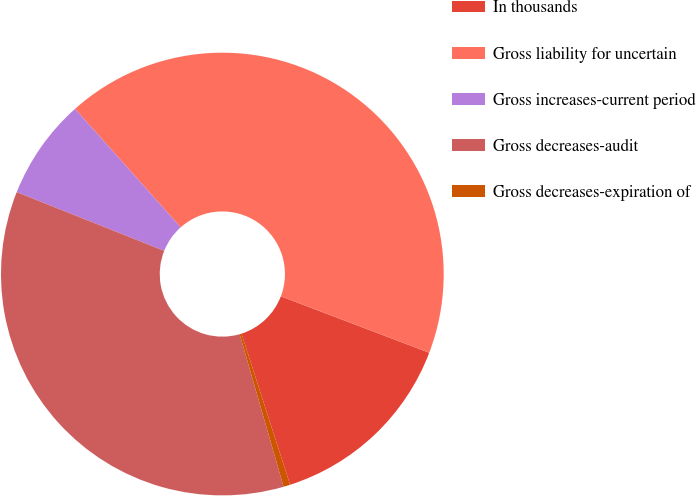Convert chart. <chart><loc_0><loc_0><loc_500><loc_500><pie_chart><fcel>In thousands<fcel>Gross liability for uncertain<fcel>Gross increases-current period<fcel>Gross decreases-audit<fcel>Gross decreases-expiration of<nl><fcel>14.26%<fcel>42.37%<fcel>7.38%<fcel>35.49%<fcel>0.49%<nl></chart> 